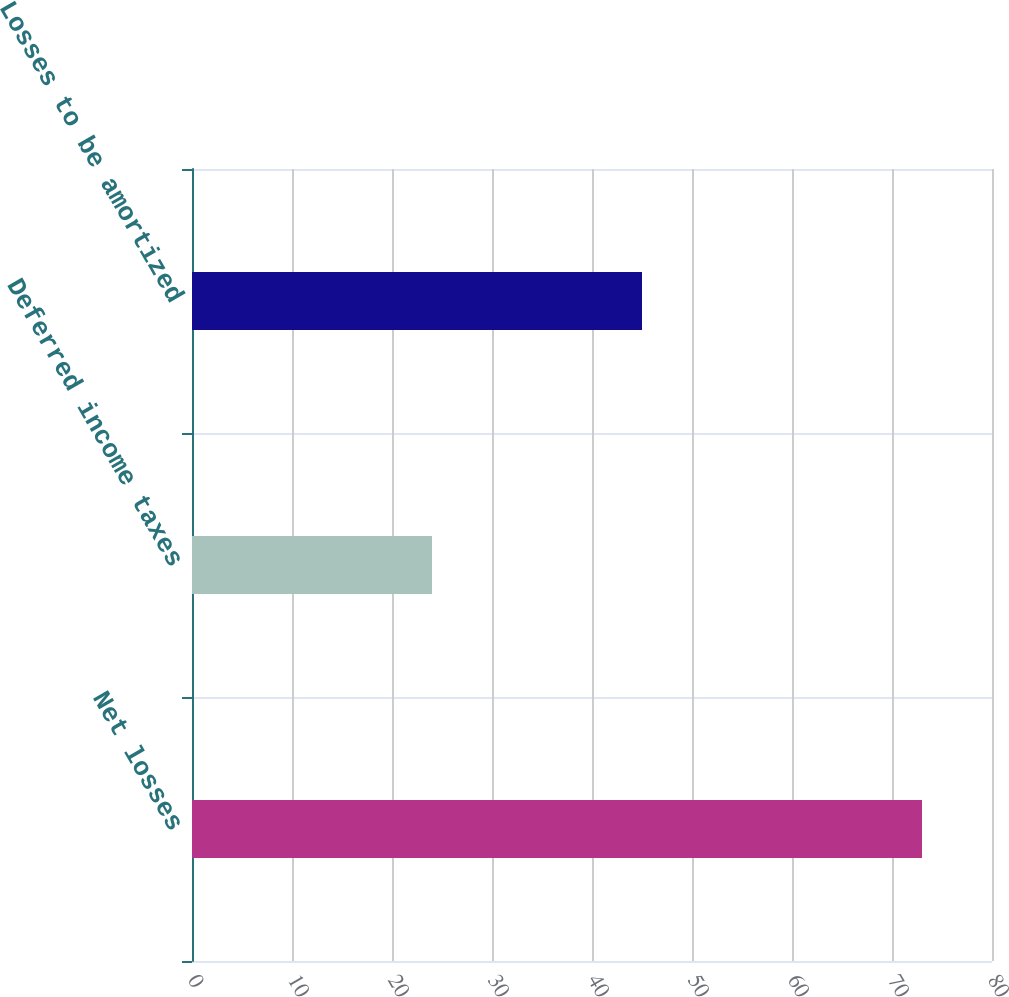Convert chart. <chart><loc_0><loc_0><loc_500><loc_500><bar_chart><fcel>Net losses<fcel>Deferred income taxes<fcel>Losses to be amortized<nl><fcel>73<fcel>24<fcel>45<nl></chart> 